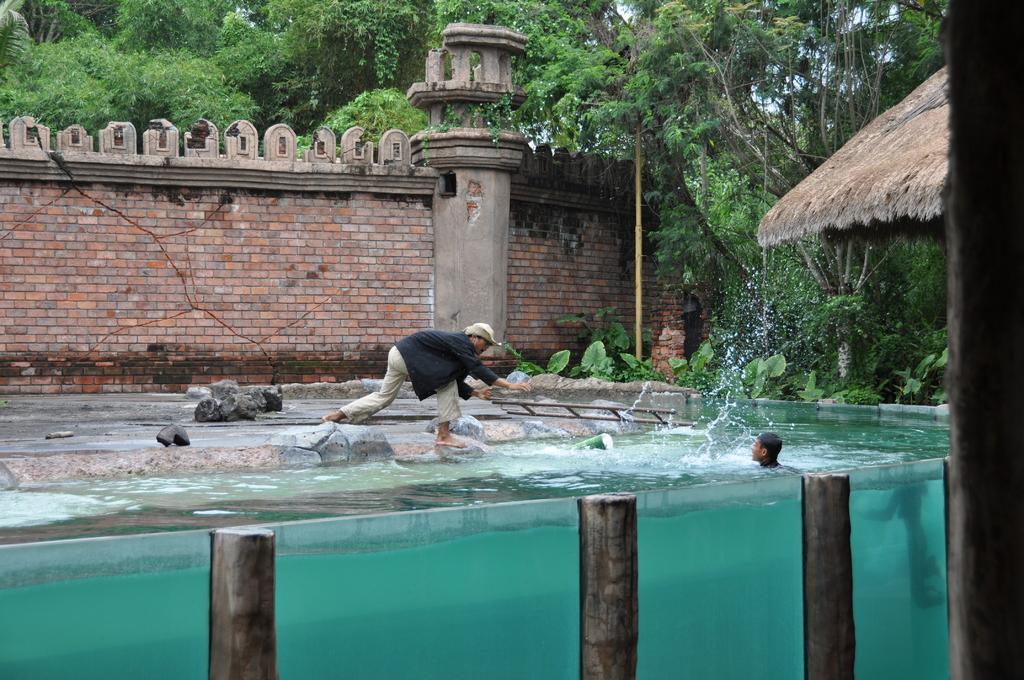Please provide a concise description of this image. In this image we can see a person in swimming pool and there is another person standing wearing black color dress and in the background of the image there is a wall and there are some trees. 